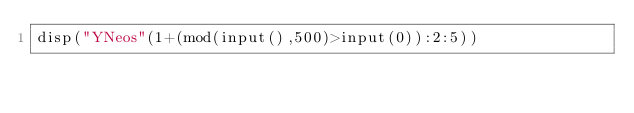<code> <loc_0><loc_0><loc_500><loc_500><_Octave_>disp("YNeos"(1+(mod(input(),500)>input(0)):2:5))</code> 